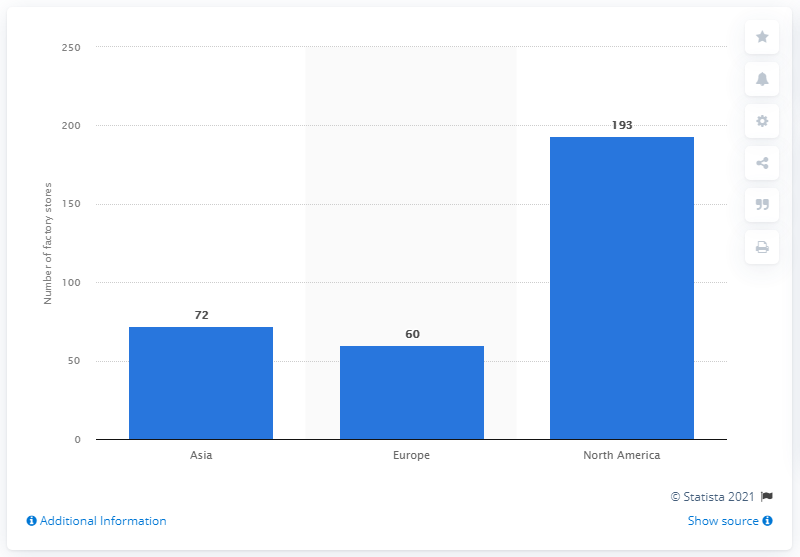Indicate a few pertinent items in this graphic. As of 2021, Polo Ralph Lauren operated 60 factory stores. 